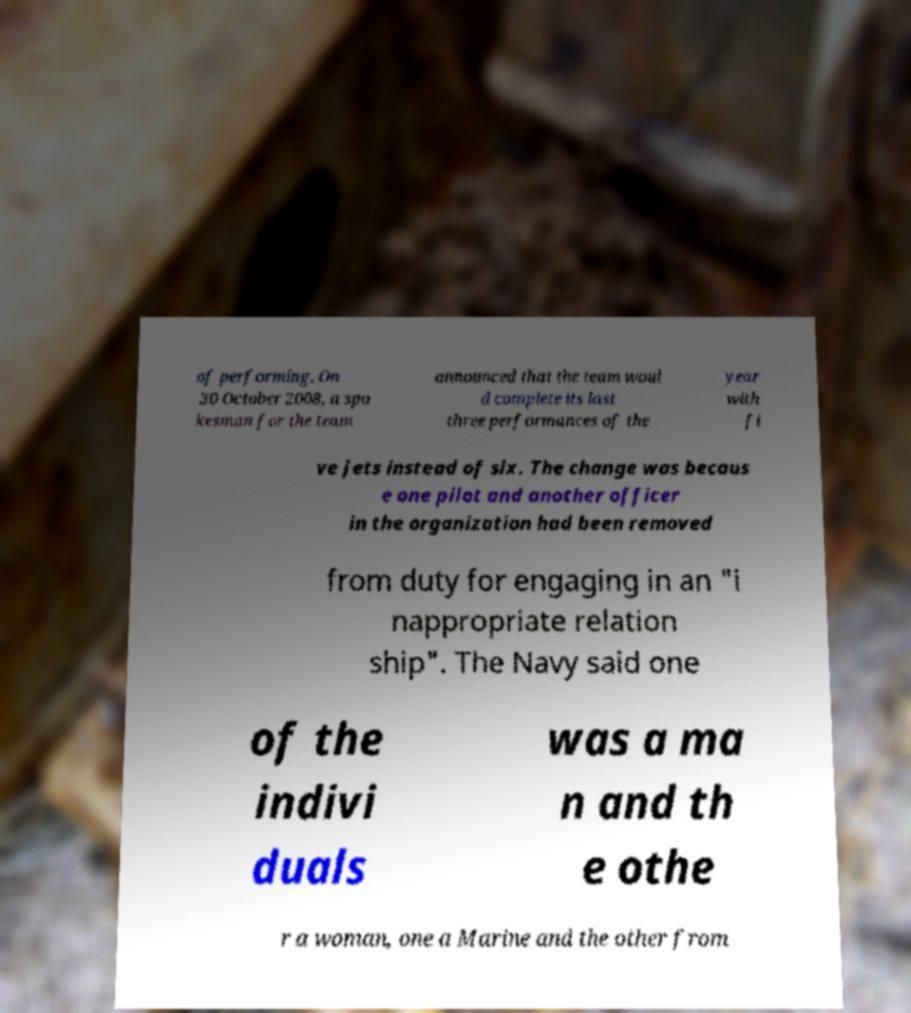What messages or text are displayed in this image? I need them in a readable, typed format. of performing. On 30 October 2008, a spo kesman for the team announced that the team woul d complete its last three performances of the year with fi ve jets instead of six. The change was becaus e one pilot and another officer in the organization had been removed from duty for engaging in an "i nappropriate relation ship". The Navy said one of the indivi duals was a ma n and th e othe r a woman, one a Marine and the other from 